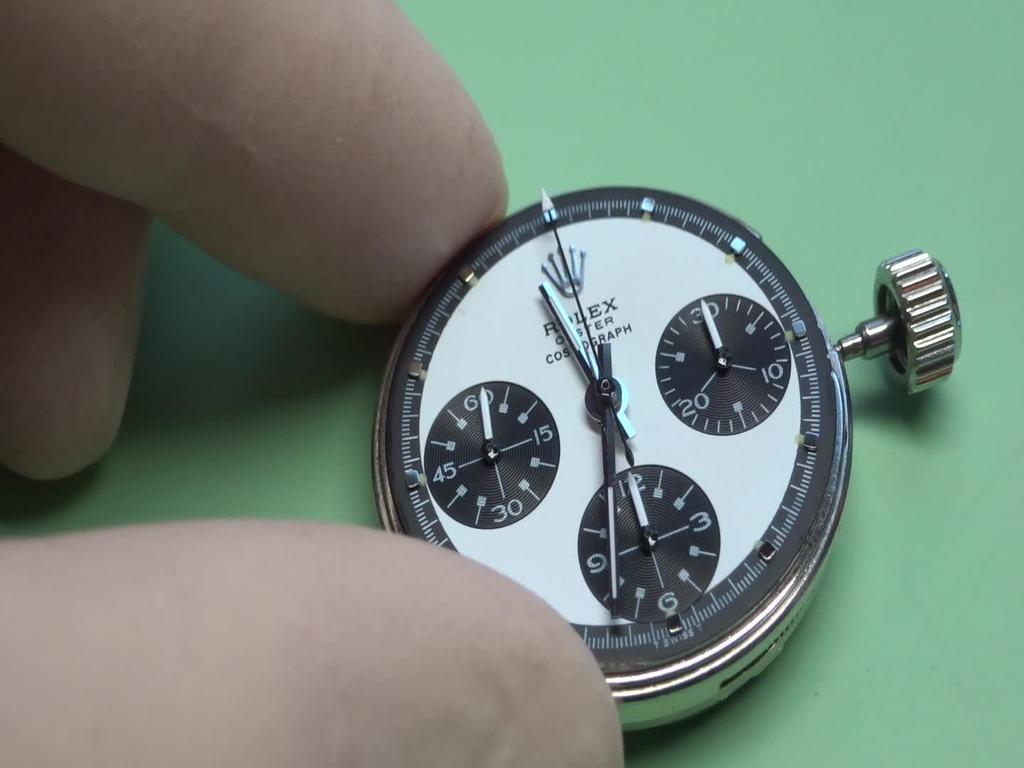Provide a one-sentence caption for the provided image. A pesons fingers holding a tiny Rolex stop watch. 